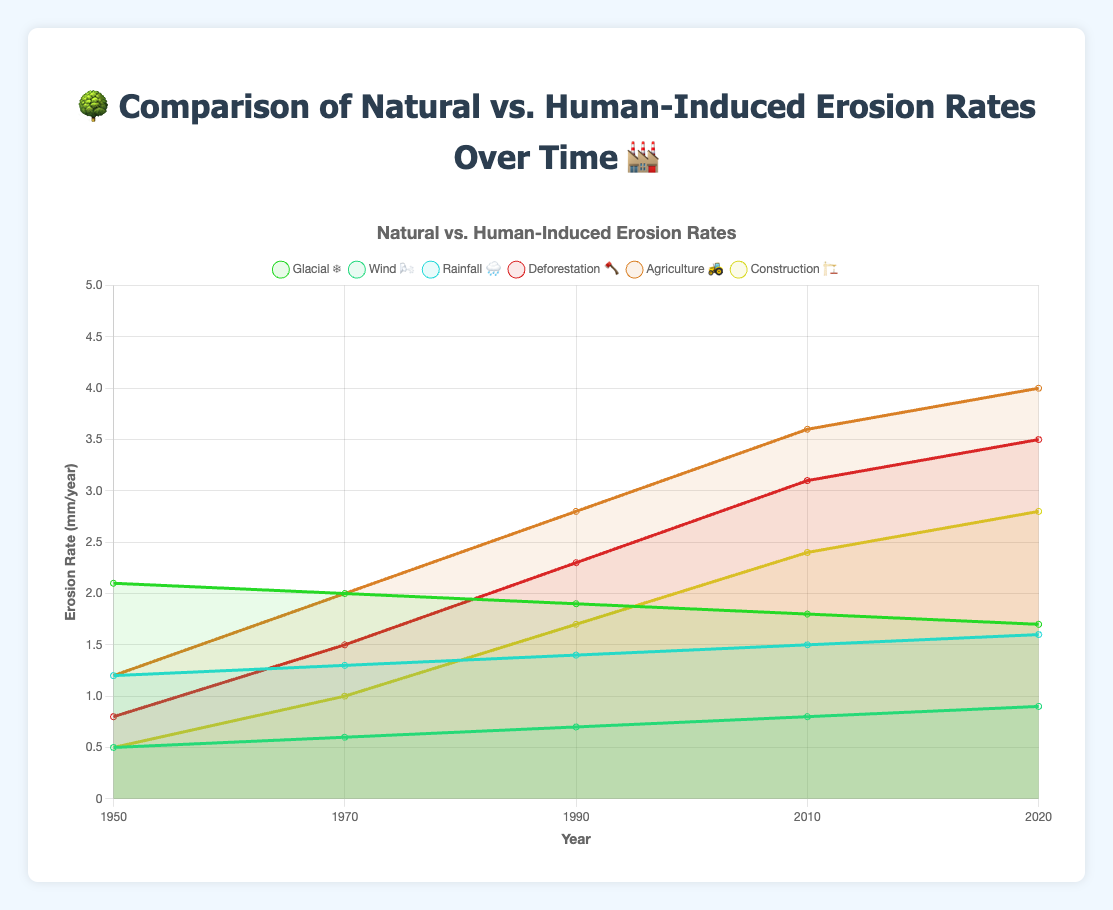How is natural erosion represented in the chart? Natural erosion is shown with different colored lines, each representing a type of natural erosion: "Glacial ❄️," "Wind 🌬️," and "Rainfall 🌧️."
Answer: As colored lines What's the highest value observed for human-induced erosion in 2020? The highest value for human-induced erosion in 2020 is for "Agriculture 🚜" at 4.0 mm/year.
Answer: 4.0 mm/year Which year shows the lowest value for glacial erosion? The chart shows that the lowest value for glacial erosion is in 2020, with a rate of 1.7 mm/year.
Answer: 2020 How does wind erosion change from 1950 to 2020? Wind erosion increases gradually from 0.5 mm/year in 1950 to 0.9 mm/year in 2020.
Answer: Increases Compare the rate of deforestation-induced erosion in 1970 to glacial erosion in the same year. In 1970, deforestation-induced erosion is 1.5 mm/year, and glacial erosion is 2.0 mm/year. Deforestation-induced erosion is lower than glacial erosion.
Answer: Lower What trend is observed in construction-induced erosion rates from 1950 to 2020? Construction-induced erosion rates show an increasing trend from 0.5 mm/year in 1950 to 2.8 mm/year in 2020.
Answer: Increasing Which type of erosion has the most consistent rate over the years? Rainfall-induced erosion shows a consistent, gradual increase over the years compared to other types of erosion.
Answer: Rainfall 🌧️ What is the total natural erosion rate in 1950? By summing up glacial, wind, and rainfall erosion rates in 1950: 2.1 + 0.5 + 1.2 = 3.8 mm/year.
Answer: 3.8 mm/year Compare agricultural erosion rates from 1990 to 2010. Agricultural erosion rates increase from 2.8 mm/year in 1990 to 3.6 mm/year in 2010, showing a rise of 0.8 mm/year.
Answer: Increase by 0.8 mm/year 